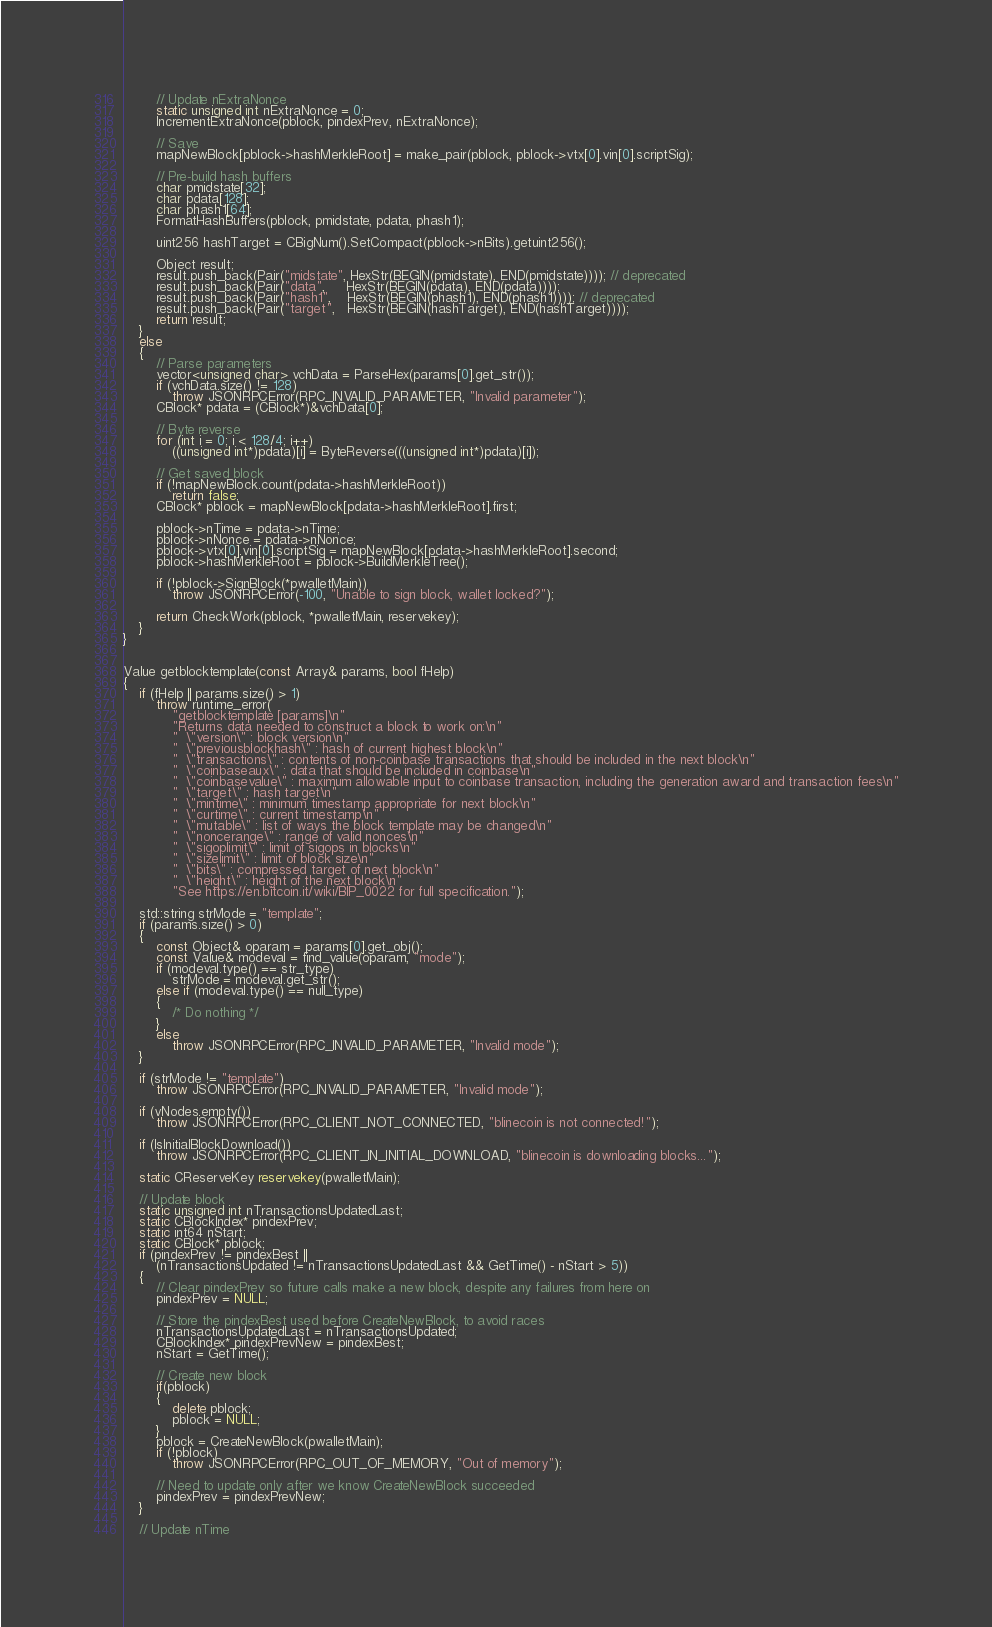Convert code to text. <code><loc_0><loc_0><loc_500><loc_500><_C++_>
        // Update nExtraNonce
        static unsigned int nExtraNonce = 0;
        IncrementExtraNonce(pblock, pindexPrev, nExtraNonce);

        // Save
        mapNewBlock[pblock->hashMerkleRoot] = make_pair(pblock, pblock->vtx[0].vin[0].scriptSig);

        // Pre-build hash buffers
        char pmidstate[32];
        char pdata[128];
        char phash1[64];
        FormatHashBuffers(pblock, pmidstate, pdata, phash1);

        uint256 hashTarget = CBigNum().SetCompact(pblock->nBits).getuint256();

        Object result;
        result.push_back(Pair("midstate", HexStr(BEGIN(pmidstate), END(pmidstate)))); // deprecated
        result.push_back(Pair("data",     HexStr(BEGIN(pdata), END(pdata))));
        result.push_back(Pair("hash1",    HexStr(BEGIN(phash1), END(phash1)))); // deprecated
        result.push_back(Pair("target",   HexStr(BEGIN(hashTarget), END(hashTarget))));
        return result;
    }
    else
    {
        // Parse parameters
        vector<unsigned char> vchData = ParseHex(params[0].get_str());
        if (vchData.size() != 128)
            throw JSONRPCError(RPC_INVALID_PARAMETER, "Invalid parameter");
        CBlock* pdata = (CBlock*)&vchData[0];

        // Byte reverse
        for (int i = 0; i < 128/4; i++)
            ((unsigned int*)pdata)[i] = ByteReverse(((unsigned int*)pdata)[i]);

        // Get saved block
        if (!mapNewBlock.count(pdata->hashMerkleRoot))
            return false;
        CBlock* pblock = mapNewBlock[pdata->hashMerkleRoot].first;

        pblock->nTime = pdata->nTime;
        pblock->nNonce = pdata->nNonce;
        pblock->vtx[0].vin[0].scriptSig = mapNewBlock[pdata->hashMerkleRoot].second;
        pblock->hashMerkleRoot = pblock->BuildMerkleTree();

        if (!pblock->SignBlock(*pwalletMain))
            throw JSONRPCError(-100, "Unable to sign block, wallet locked?");

        return CheckWork(pblock, *pwalletMain, reservekey);
    }
}


Value getblocktemplate(const Array& params, bool fHelp)
{
    if (fHelp || params.size() > 1)
        throw runtime_error(
            "getblocktemplate [params]\n"
            "Returns data needed to construct a block to work on:\n"
            "  \"version\" : block version\n"
            "  \"previousblockhash\" : hash of current highest block\n"
            "  \"transactions\" : contents of non-coinbase transactions that should be included in the next block\n"
            "  \"coinbaseaux\" : data that should be included in coinbase\n"
            "  \"coinbasevalue\" : maximum allowable input to coinbase transaction, including the generation award and transaction fees\n"
            "  \"target\" : hash target\n"
            "  \"mintime\" : minimum timestamp appropriate for next block\n"
            "  \"curtime\" : current timestamp\n"
            "  \"mutable\" : list of ways the block template may be changed\n"
            "  \"noncerange\" : range of valid nonces\n"
            "  \"sigoplimit\" : limit of sigops in blocks\n"
            "  \"sizelimit\" : limit of block size\n"
            "  \"bits\" : compressed target of next block\n"
            "  \"height\" : height of the next block\n"
            "See https://en.bitcoin.it/wiki/BIP_0022 for full specification.");

    std::string strMode = "template";
    if (params.size() > 0)
    {
        const Object& oparam = params[0].get_obj();
        const Value& modeval = find_value(oparam, "mode");
        if (modeval.type() == str_type)
            strMode = modeval.get_str();
        else if (modeval.type() == null_type)
        {
            /* Do nothing */
        }
        else
            throw JSONRPCError(RPC_INVALID_PARAMETER, "Invalid mode");
    }

    if (strMode != "template")
        throw JSONRPCError(RPC_INVALID_PARAMETER, "Invalid mode");

    if (vNodes.empty())
        throw JSONRPCError(RPC_CLIENT_NOT_CONNECTED, "blinecoin is not connected!");

    if (IsInitialBlockDownload())
        throw JSONRPCError(RPC_CLIENT_IN_INITIAL_DOWNLOAD, "blinecoin is downloading blocks...");

    static CReserveKey reservekey(pwalletMain);

    // Update block
    static unsigned int nTransactionsUpdatedLast;
    static CBlockIndex* pindexPrev;
    static int64 nStart;
    static CBlock* pblock;
    if (pindexPrev != pindexBest ||
        (nTransactionsUpdated != nTransactionsUpdatedLast && GetTime() - nStart > 5))
    {
        // Clear pindexPrev so future calls make a new block, despite any failures from here on
        pindexPrev = NULL;

        // Store the pindexBest used before CreateNewBlock, to avoid races
        nTransactionsUpdatedLast = nTransactionsUpdated;
        CBlockIndex* pindexPrevNew = pindexBest;
        nStart = GetTime();

        // Create new block
        if(pblock)
        {
            delete pblock;
            pblock = NULL;
        }
        pblock = CreateNewBlock(pwalletMain);
        if (!pblock)
            throw JSONRPCError(RPC_OUT_OF_MEMORY, "Out of memory");

        // Need to update only after we know CreateNewBlock succeeded
        pindexPrev = pindexPrevNew;
    }

    // Update nTime</code> 